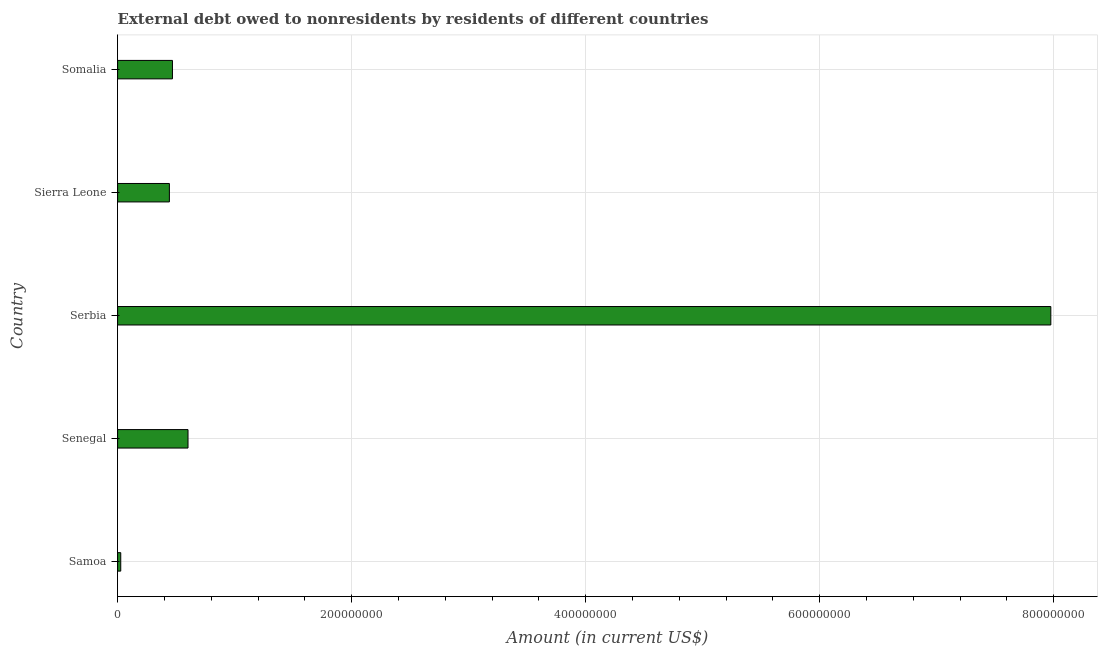Does the graph contain any zero values?
Provide a short and direct response. No. What is the title of the graph?
Offer a very short reply. External debt owed to nonresidents by residents of different countries. What is the debt in Somalia?
Provide a short and direct response. 4.69e+07. Across all countries, what is the maximum debt?
Your answer should be compact. 7.98e+08. Across all countries, what is the minimum debt?
Give a very brief answer. 2.68e+06. In which country was the debt maximum?
Offer a terse response. Serbia. In which country was the debt minimum?
Give a very brief answer. Samoa. What is the sum of the debt?
Your answer should be compact. 9.52e+08. What is the difference between the debt in Serbia and Somalia?
Give a very brief answer. 7.51e+08. What is the average debt per country?
Your answer should be very brief. 1.90e+08. What is the median debt?
Offer a very short reply. 4.69e+07. In how many countries, is the debt greater than 520000000 US$?
Offer a very short reply. 1. What is the ratio of the debt in Samoa to that in Senegal?
Your response must be concise. 0.04. Is the debt in Samoa less than that in Sierra Leone?
Provide a short and direct response. Yes. Is the difference between the debt in Serbia and Sierra Leone greater than the difference between any two countries?
Give a very brief answer. No. What is the difference between the highest and the second highest debt?
Keep it short and to the point. 7.37e+08. Is the sum of the debt in Samoa and Sierra Leone greater than the maximum debt across all countries?
Provide a short and direct response. No. What is the difference between the highest and the lowest debt?
Offer a very short reply. 7.95e+08. In how many countries, is the debt greater than the average debt taken over all countries?
Offer a very short reply. 1. What is the Amount (in current US$) of Samoa?
Your response must be concise. 2.68e+06. What is the Amount (in current US$) in Senegal?
Make the answer very short. 6.02e+07. What is the Amount (in current US$) of Serbia?
Your answer should be very brief. 7.98e+08. What is the Amount (in current US$) of Sierra Leone?
Provide a succinct answer. 4.43e+07. What is the Amount (in current US$) of Somalia?
Ensure brevity in your answer.  4.69e+07. What is the difference between the Amount (in current US$) in Samoa and Senegal?
Provide a succinct answer. -5.75e+07. What is the difference between the Amount (in current US$) in Samoa and Serbia?
Keep it short and to the point. -7.95e+08. What is the difference between the Amount (in current US$) in Samoa and Sierra Leone?
Make the answer very short. -4.16e+07. What is the difference between the Amount (in current US$) in Samoa and Somalia?
Offer a terse response. -4.42e+07. What is the difference between the Amount (in current US$) in Senegal and Serbia?
Your answer should be compact. -7.37e+08. What is the difference between the Amount (in current US$) in Senegal and Sierra Leone?
Provide a succinct answer. 1.59e+07. What is the difference between the Amount (in current US$) in Senegal and Somalia?
Keep it short and to the point. 1.33e+07. What is the difference between the Amount (in current US$) in Serbia and Sierra Leone?
Your answer should be compact. 7.53e+08. What is the difference between the Amount (in current US$) in Serbia and Somalia?
Provide a succinct answer. 7.51e+08. What is the difference between the Amount (in current US$) in Sierra Leone and Somalia?
Ensure brevity in your answer.  -2.61e+06. What is the ratio of the Amount (in current US$) in Samoa to that in Senegal?
Keep it short and to the point. 0.04. What is the ratio of the Amount (in current US$) in Samoa to that in Serbia?
Ensure brevity in your answer.  0. What is the ratio of the Amount (in current US$) in Samoa to that in Sierra Leone?
Provide a short and direct response. 0.06. What is the ratio of the Amount (in current US$) in Samoa to that in Somalia?
Provide a succinct answer. 0.06. What is the ratio of the Amount (in current US$) in Senegal to that in Serbia?
Provide a succinct answer. 0.07. What is the ratio of the Amount (in current US$) in Senegal to that in Sierra Leone?
Offer a very short reply. 1.36. What is the ratio of the Amount (in current US$) in Senegal to that in Somalia?
Your response must be concise. 1.28. What is the ratio of the Amount (in current US$) in Serbia to that in Sierra Leone?
Keep it short and to the point. 18.02. What is the ratio of the Amount (in current US$) in Serbia to that in Somalia?
Provide a succinct answer. 17.02. What is the ratio of the Amount (in current US$) in Sierra Leone to that in Somalia?
Your answer should be compact. 0.94. 